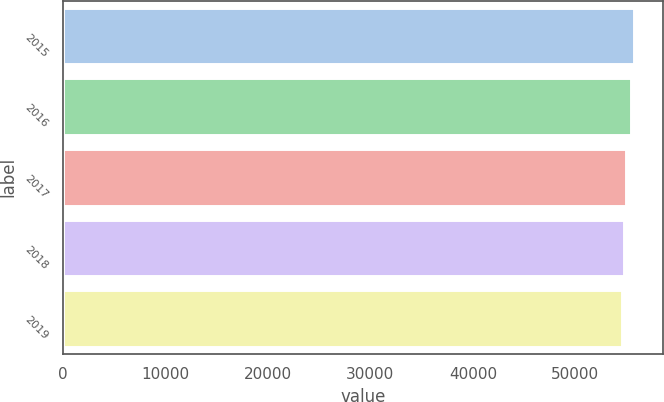Convert chart to OTSL. <chart><loc_0><loc_0><loc_500><loc_500><bar_chart><fcel>2015<fcel>2016<fcel>2017<fcel>2018<fcel>2019<nl><fcel>55750<fcel>55400<fcel>54950<fcel>54700<fcel>54500<nl></chart> 